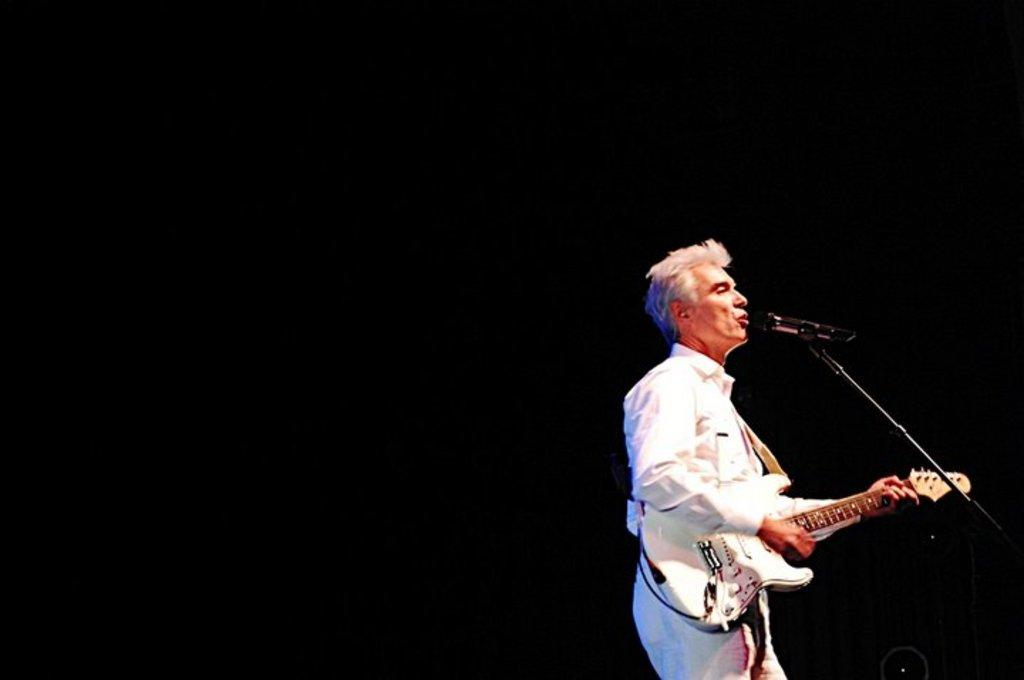What is the gender of the person in the image? The person in the image is a man. What is the man doing in the image? The man is standing and holding a guitar. What equipment is present in the image for amplifying sound? There is a microphone and a microphone stand in the image. What type of sidewalk can be seen in the image? There is no sidewalk present in the image. How many horses are visible in the image? There are no horses present in the image. 